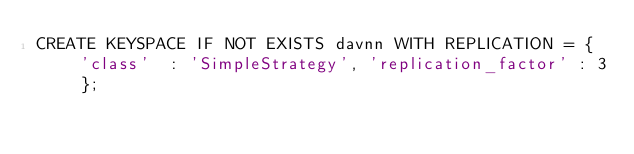<code> <loc_0><loc_0><loc_500><loc_500><_SQL_>CREATE KEYSPACE IF NOT EXISTS davnn WITH REPLICATION = {  'class'  : 'SimpleStrategy', 'replication_factor' : 3 };</code> 